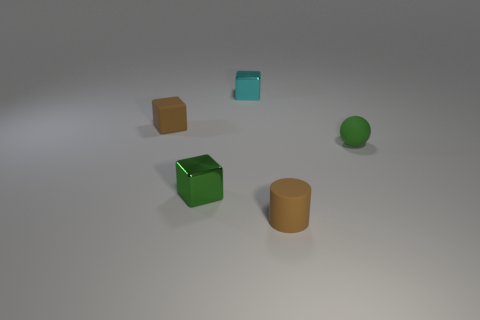Does the small matte object that is in front of the small ball have the same color as the small matte cube?
Provide a short and direct response. Yes. What material is the tiny cylinder that is the same color as the tiny rubber block?
Offer a terse response. Rubber. Do the metal thing that is in front of the cyan block and the brown cylinder have the same size?
Offer a terse response. Yes. Is there a shiny cube that has the same color as the tiny matte block?
Make the answer very short. No. Is there a rubber object on the right side of the small matte thing that is right of the small matte cylinder?
Your answer should be compact. No. Is there a green sphere made of the same material as the cyan object?
Provide a short and direct response. No. What is the material of the green object that is right of the brown rubber object that is in front of the matte cube?
Your answer should be very brief. Rubber. There is a tiny thing that is right of the cyan shiny thing and on the left side of the sphere; what is its material?
Provide a short and direct response. Rubber. Are there the same number of brown rubber blocks that are in front of the rubber ball and metallic things?
Ensure brevity in your answer.  No. What number of rubber objects are the same shape as the small cyan metallic thing?
Your answer should be very brief. 1. 